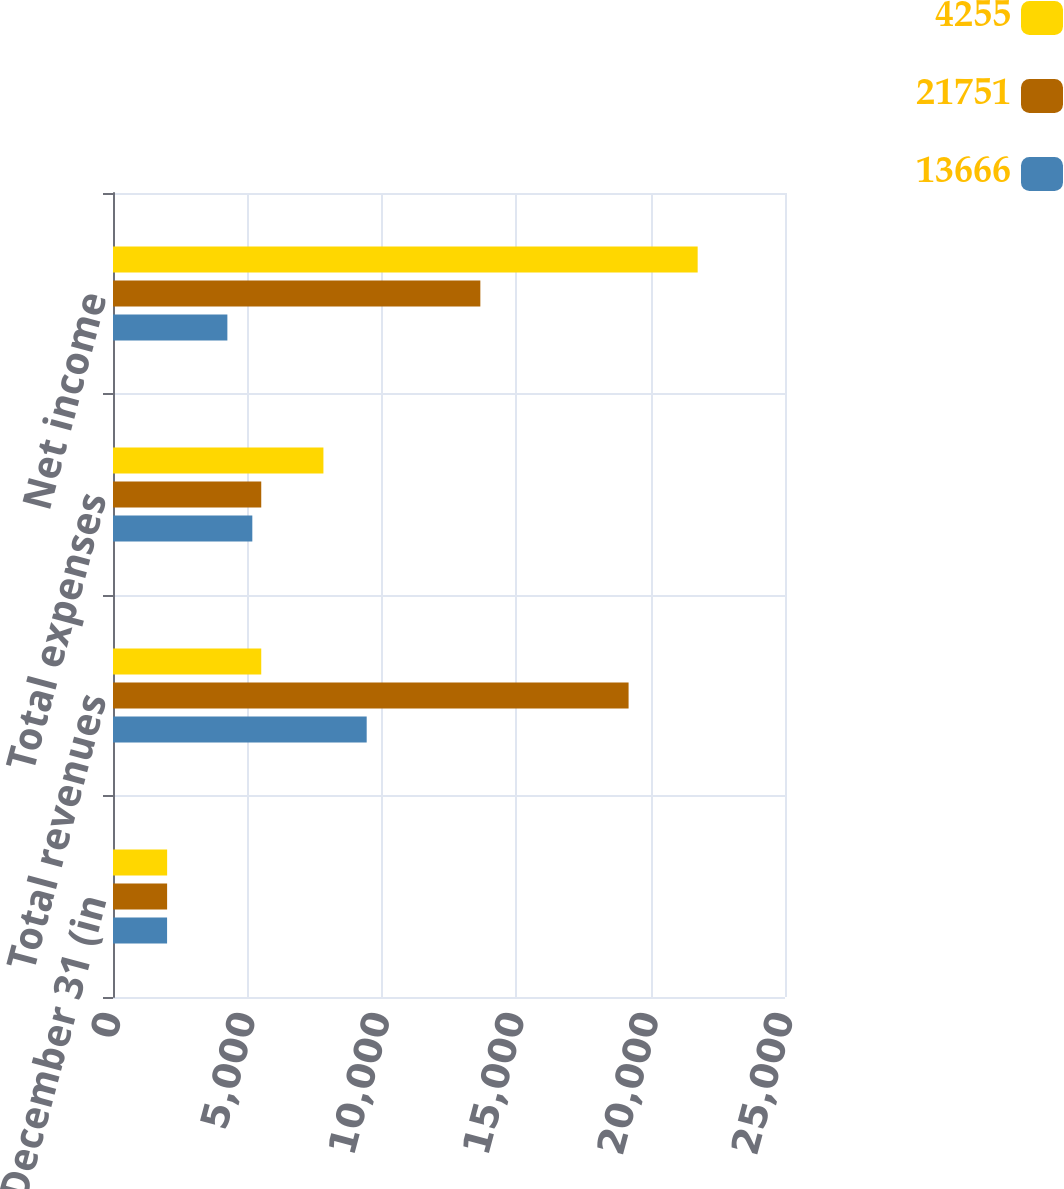Convert chart to OTSL. <chart><loc_0><loc_0><loc_500><loc_500><stacked_bar_chart><ecel><fcel>Years Ended December 31 (in<fcel>Total revenues<fcel>Total expenses<fcel>Net income<nl><fcel>4255<fcel>2014<fcel>5515<fcel>7828<fcel>21751<nl><fcel>21751<fcel>2013<fcel>19181<fcel>5515<fcel>13666<nl><fcel>13666<fcel>2012<fcel>9438<fcel>5183<fcel>4255<nl></chart> 